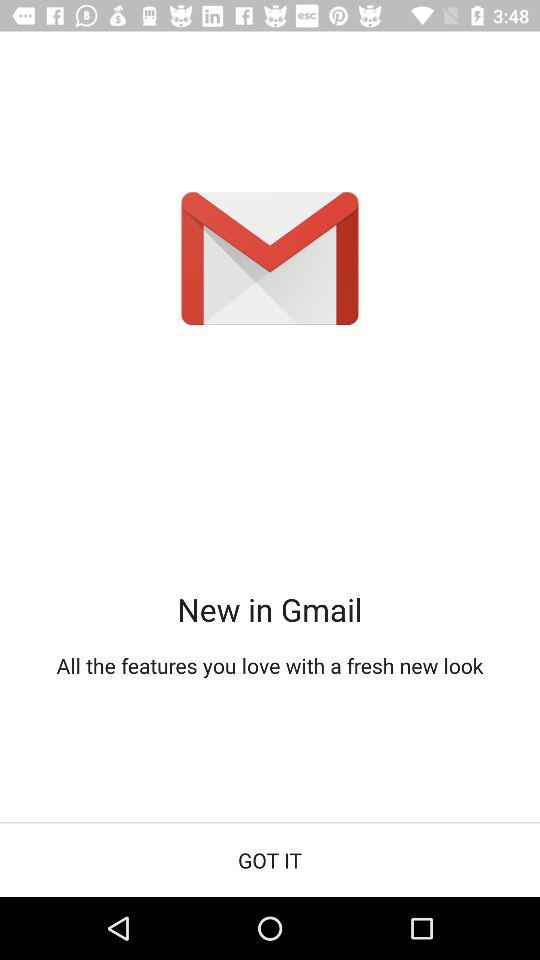What is the app name? The app name is "Gmail". 